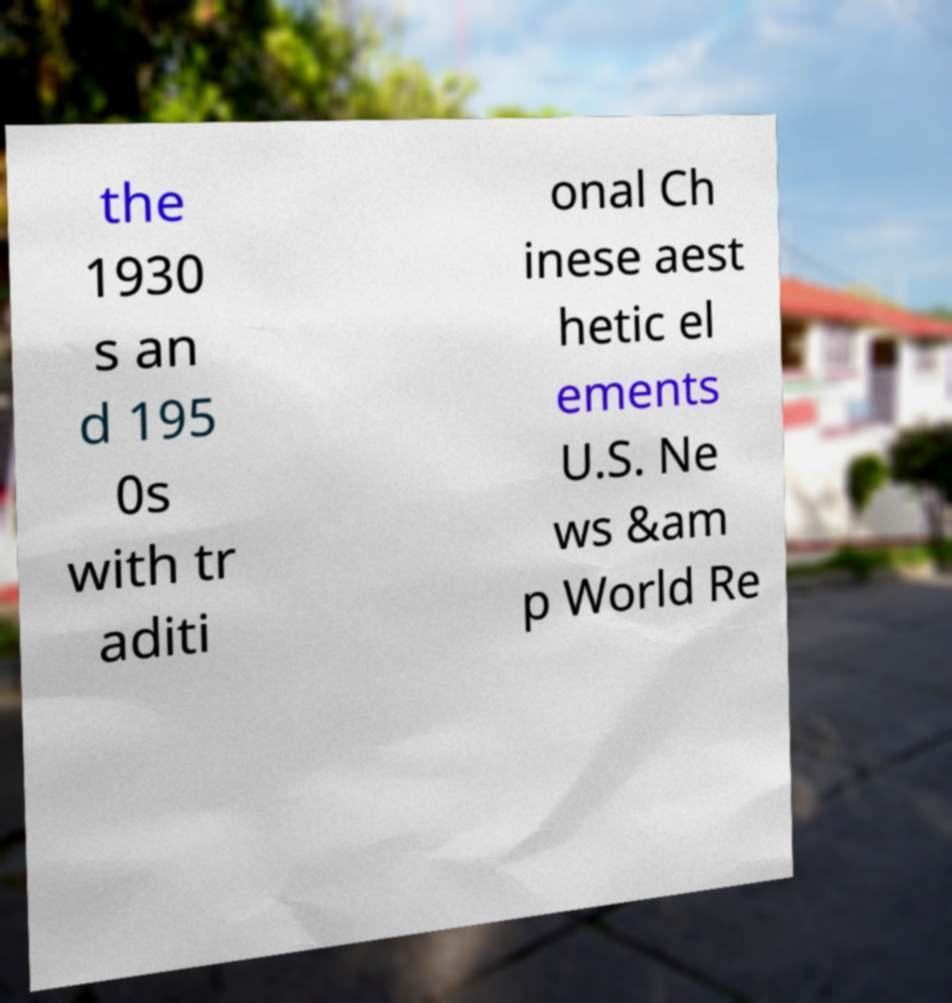Can you accurately transcribe the text from the provided image for me? the 1930 s an d 195 0s with tr aditi onal Ch inese aest hetic el ements U.S. Ne ws &am p World Re 